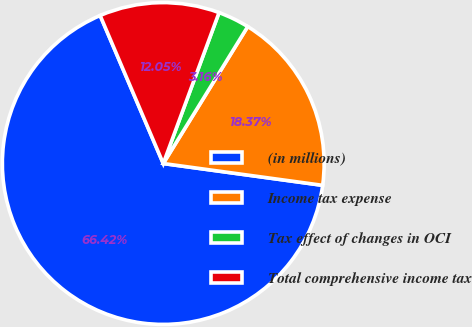Convert chart. <chart><loc_0><loc_0><loc_500><loc_500><pie_chart><fcel>(in millions)<fcel>Income tax expense<fcel>Tax effect of changes in OCI<fcel>Total comprehensive income tax<nl><fcel>66.42%<fcel>18.37%<fcel>3.16%<fcel>12.05%<nl></chart> 